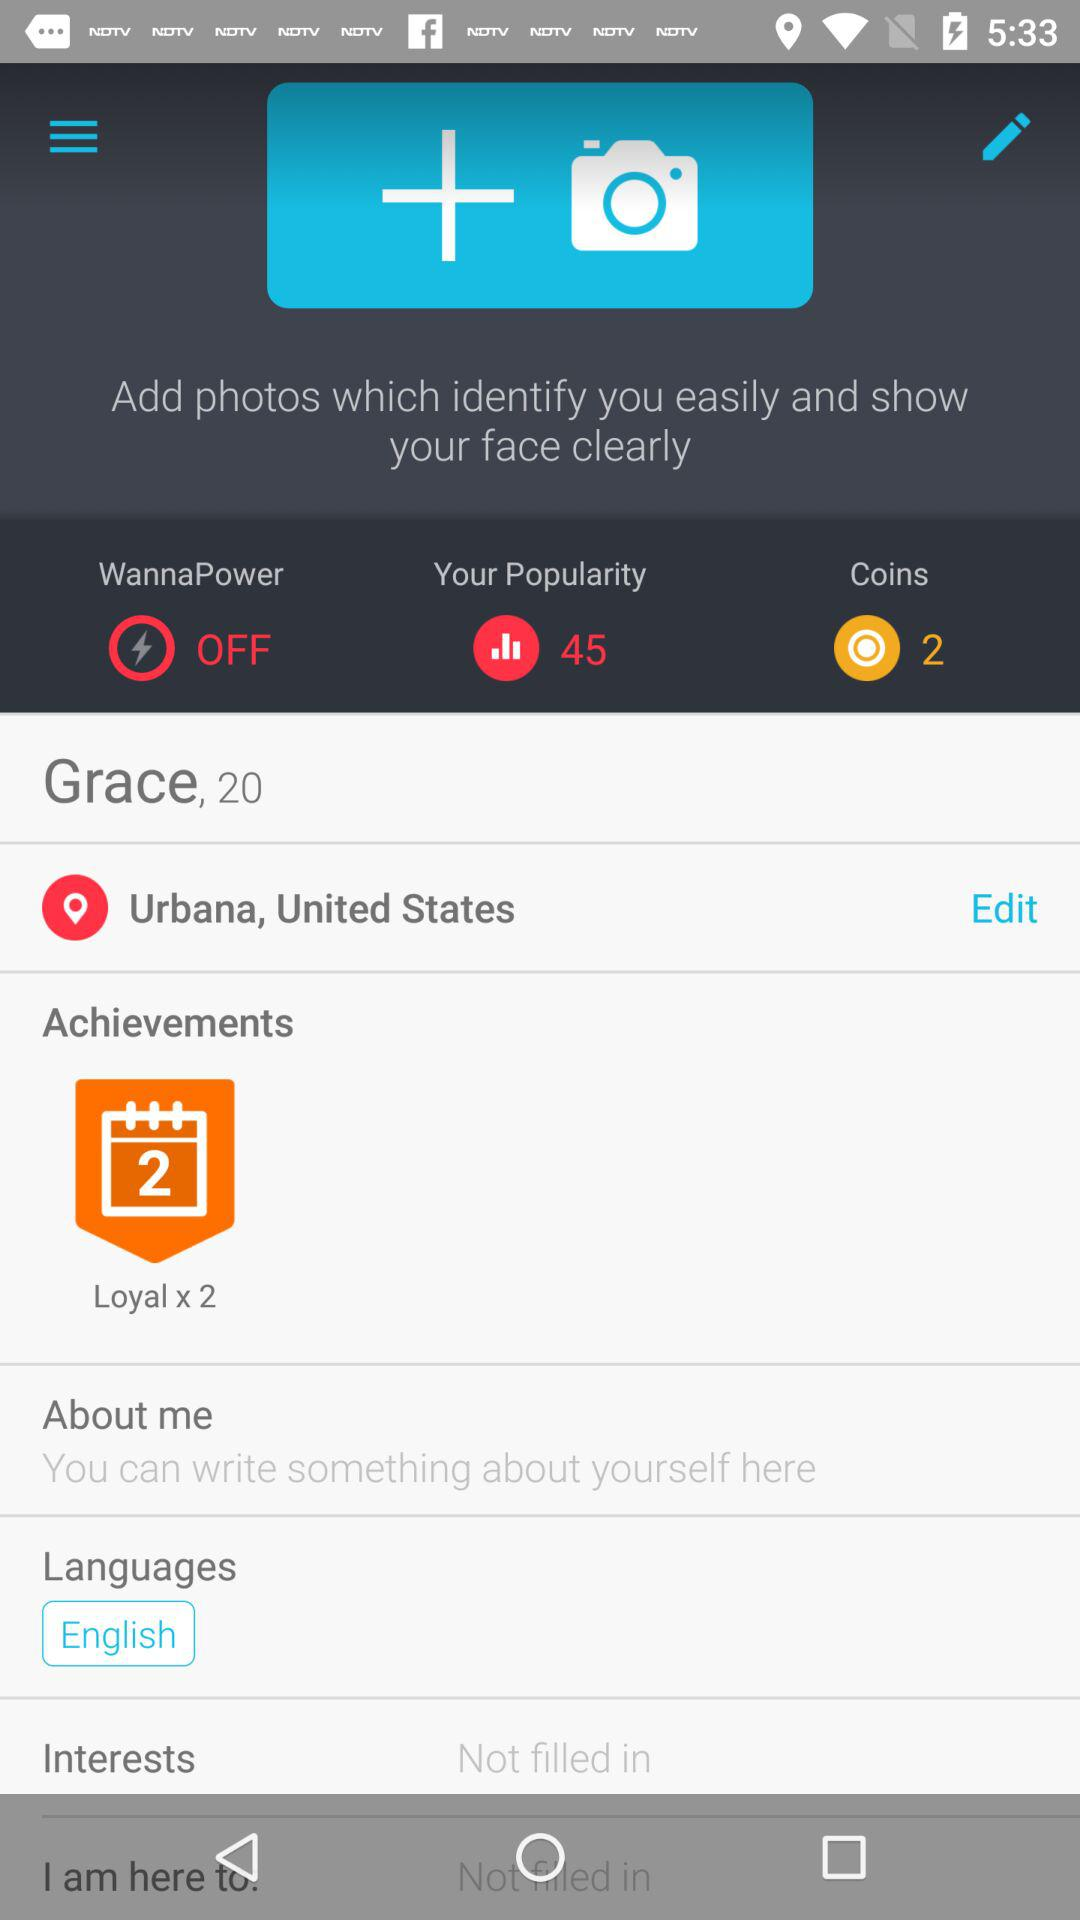What are the numbers of coins? The number of coins is 2. 